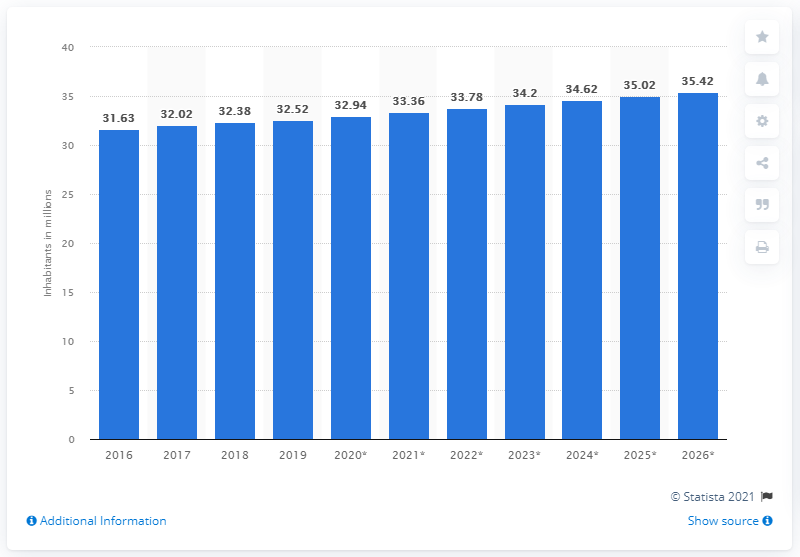Point out several critical features in this image. In 2019, the population of Malaysia was approximately 32.52 million people. 